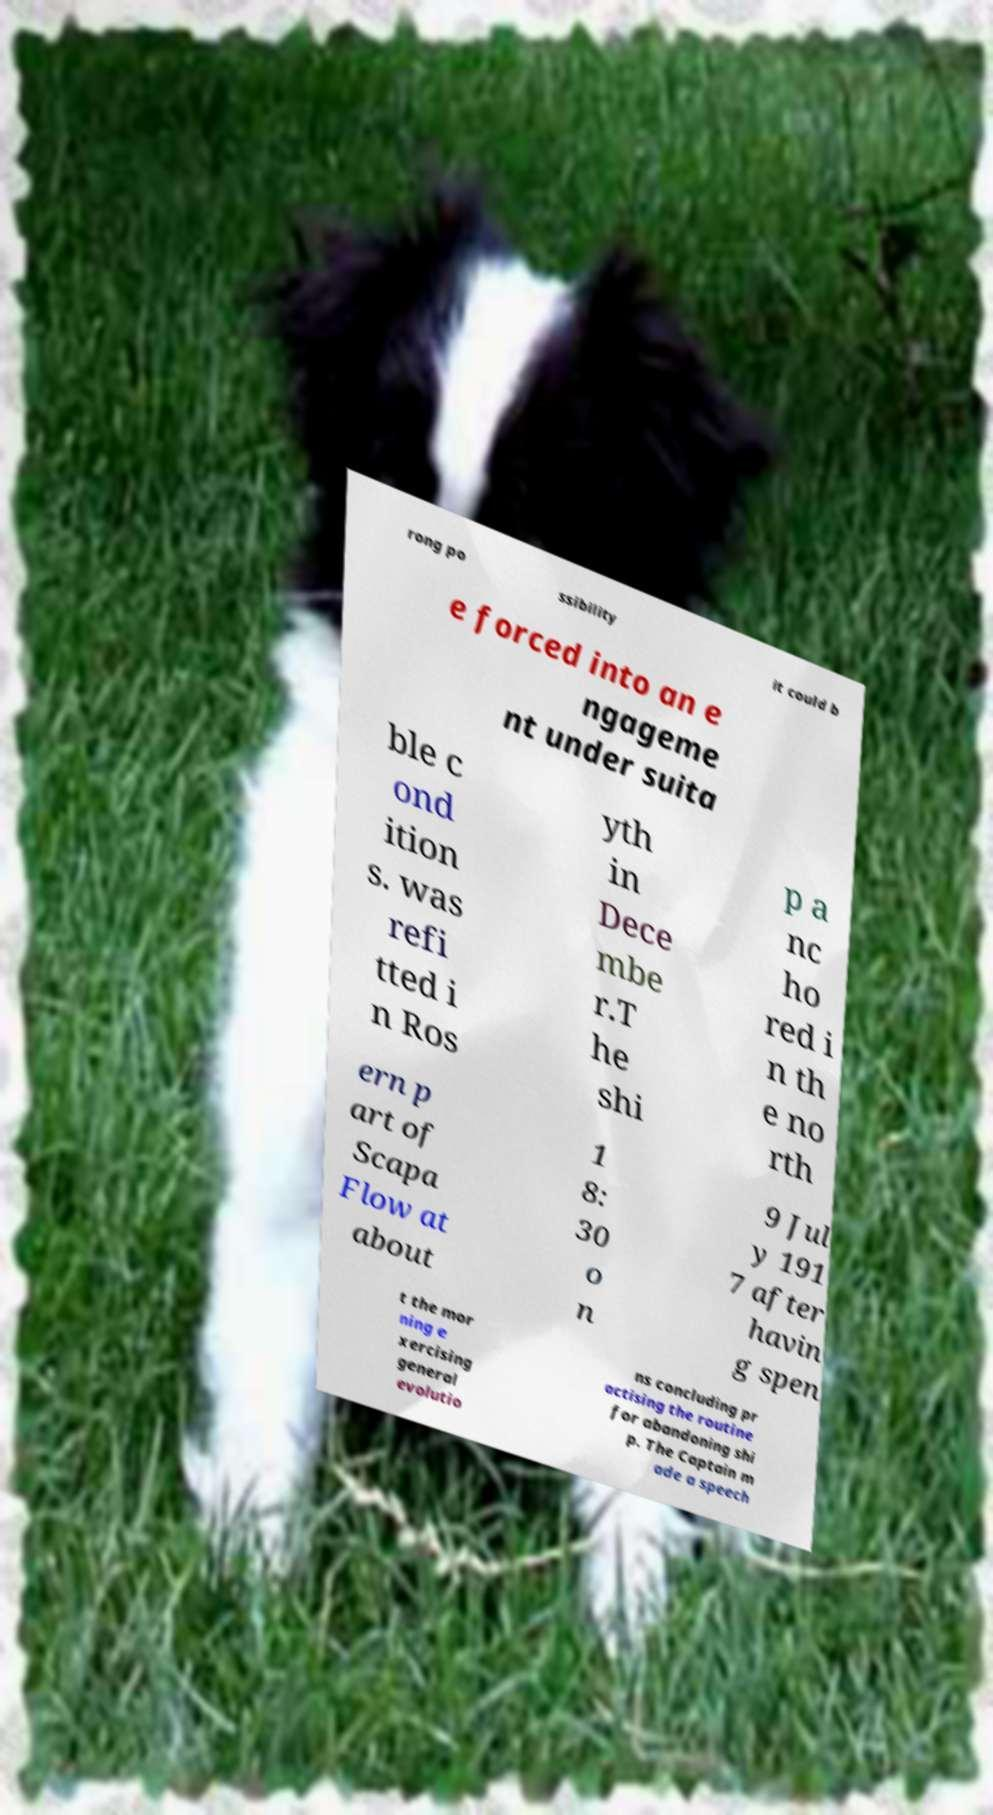Please read and relay the text visible in this image. What does it say? rong po ssibility it could b e forced into an e ngageme nt under suita ble c ond ition s. was refi tted i n Ros yth in Dece mbe r.T he shi p a nc ho red i n th e no rth ern p art of Scapa Flow at about 1 8: 30 o n 9 Jul y 191 7 after havin g spen t the mor ning e xercising general evolutio ns concluding pr actising the routine for abandoning shi p. The Captain m ade a speech 